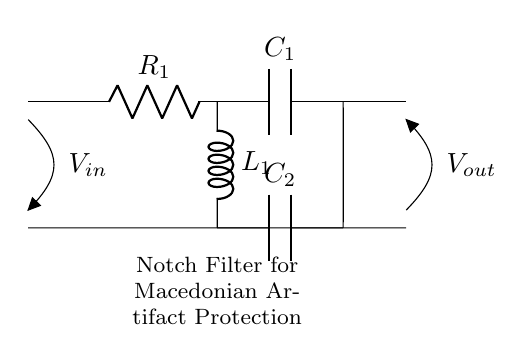What are the components used in this circuit? The components in the circuit are a resistor (R1), capacitor (C1), inductor (L1), and another capacitor (C2). They are essential parts used in the notch filter to reduce specific frequency interferences.
Answer: Resistor, Capacitor, Inductor What is the purpose of this circuit? The purpose of the circuit is to act as a notch filter, which is designed to remove electrical interference from security systems in museums protecting artifacts. The filter targets specific frequencies to improve signal quality.
Answer: Notch filter How many capacitors are present in this circuit? There are two capacitors labeled C1 and C2 in the circuit, which are crucial for the filter's operation by allowing certain frequencies to pass while blocking others.
Answer: Two What is the type of filter represented in this circuit? The type of filter in this circuit is a notch filter, which specifically eliminates a narrow range of frequencies to reduce unwanted electrical noise.
Answer: Notch filter What connects R1 and C1? R1 and C1 are connected in series, with R1 providing resistance and C1 providing capacitance, which is typical in filter circuits for determining the cutoff frequencies.
Answer: Series connection What does V_in represent in this circuit? V_in represents the input voltage to the notch filter, which is the voltage applied at the start of the circuit to be filtered.
Answer: Input voltage What occurs at the output V_out? At V_out, the filtered voltage appears, which has had specific frequency components removed due to the operation of the notch filter, enhancing signal quality for museum security.
Answer: Filtered voltage 